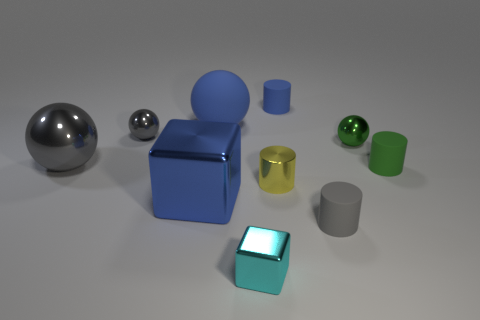Subtract all blocks. How many objects are left? 8 Add 5 tiny gray spheres. How many tiny gray spheres exist? 6 Subtract 0 purple cylinders. How many objects are left? 10 Subtract all large blue things. Subtract all small gray cylinders. How many objects are left? 7 Add 1 blue matte balls. How many blue matte balls are left? 2 